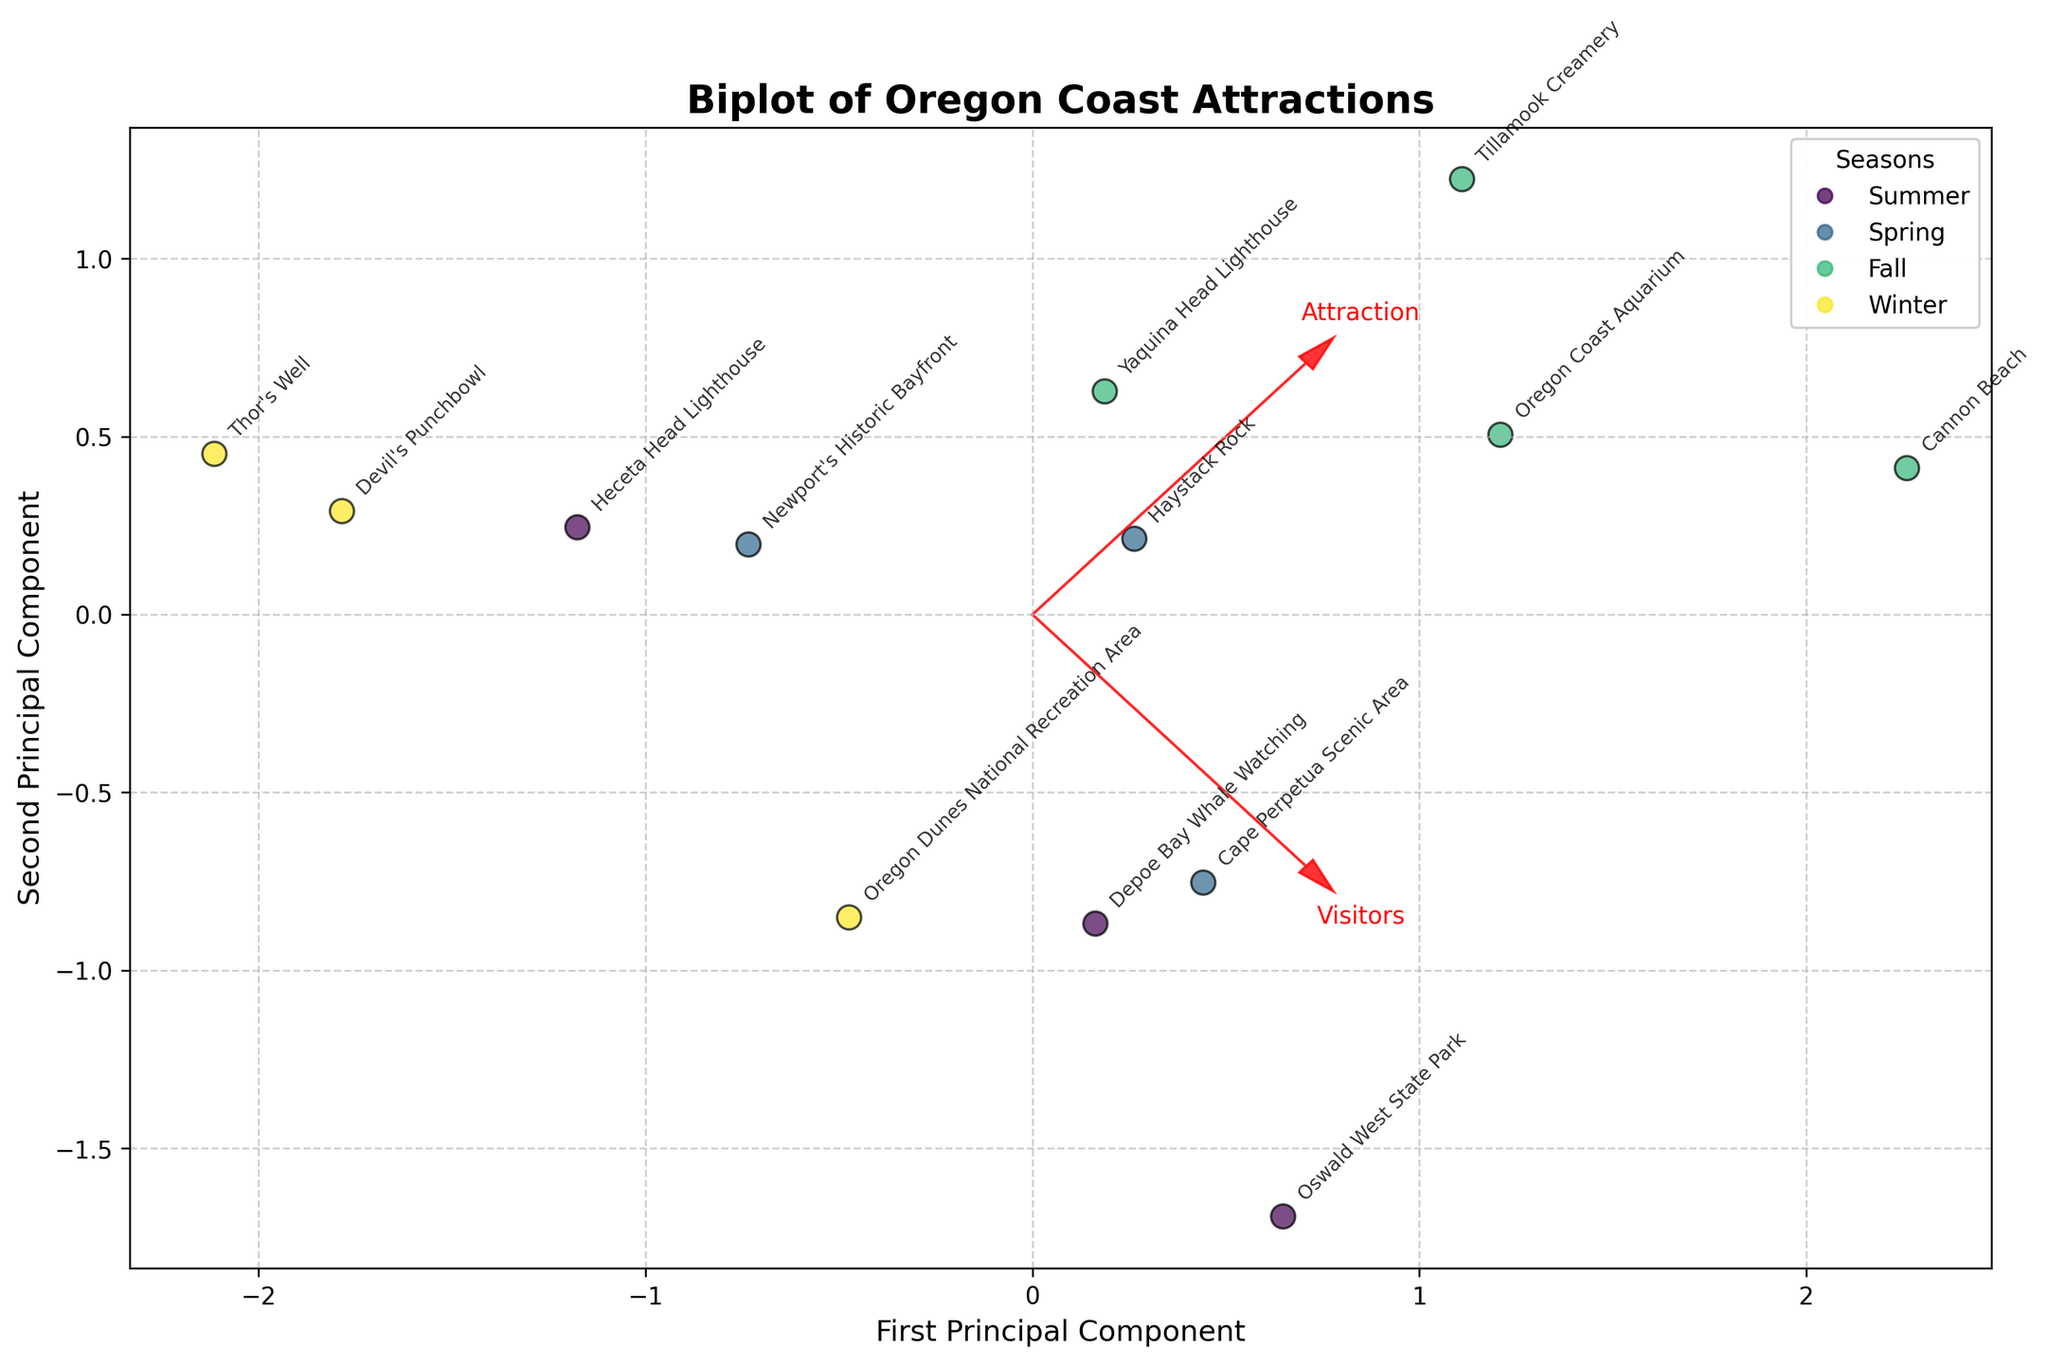What is the title of the biplot? The title of the plot is displayed prominently at the top and usually describes the main subject of the plot. Here, it reads "Biplot of Oregon Coast Attractions."
Answer: Biplot of Oregon Coast Attractions What do the arrows in the biplot represent? The arrows represent the feature vectors of the principal components. They indicate the direction and magnitude of the original variables, which in this case are 'Visitors' and 'Duration.'
Answer: Feature vectors of 'Visitors' and 'Duration' How many distinct seasons are represented in the plot? By looking at the legend, we can see that there are four distinct colors representing different seasons. The legend lists them as Summer, Spring, Fall, and Winter.
Answer: Four Which season's attractions appear to have the highest visitor numbers? By observing the position of the points and their colors, the attractions in the Summer season (usually depicted by a specific color) tend to be clustered farther from the origin on the direction of the 'Visitors' arrow, indicating higher visitor numbers.
Answer: Summer What is the relationship between 'Visitors' and the first principal component? In a biplot, the direction of an arrow shows the relationship with the principal components. The 'Visitors' arrow points in the direction of the first principal component, indicating a strong positive relationship.
Answer: Strong positive relationship Are there any attractions associated with longer durations that are visited more in the Spring or Fall? By examining the colors and the placement along the 'Duration' vector, attractions in Spring and Fall (moderate colors) placed farther from the origin on the direction of the 'Duration' arrow indicate longer durations. Attractions like Cape Perpetua Scenic Area (Spring) and Oswald West State Park (Fall) are examples.
Answer: Yes Which season has the least visited attractions? Observing the points closest to the origin relative to the 'Visitors' axis and their associated colors, Winter attractions are positioned closest to the origin, indicating the least visited attractions.
Answer: Winter What can we infer about 'Tillamook Creamery' from the biplot? By looking at the labeled point for 'Tillamook Creamery,' we can see it lies far along the 'Visitors' vector and is marked with the color representing Summer, indicating it has high visitor numbers during the Summer season.
Answer: High visitor numbers in Summer How does 'Duration' for Fall attractions compare to those in Winter? Observing the placement of points for Fall (moderate color) and Winter (another specific color) along the 'Duration' vector, Fall attractions such as Oswald West State Park are farther along this axis than Winter attractions, indicating longer durations.
Answer: Fall attractions have longer durations than Winter attractions 